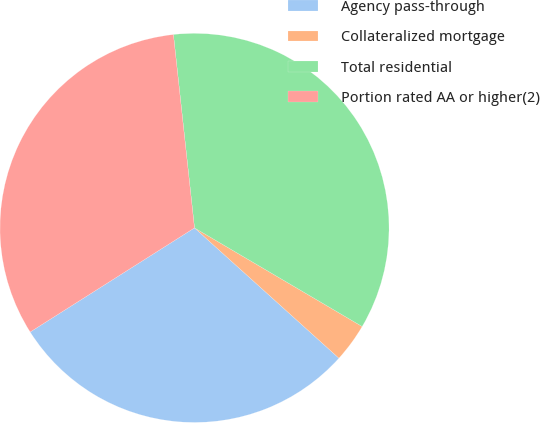<chart> <loc_0><loc_0><loc_500><loc_500><pie_chart><fcel>Agency pass-through<fcel>Collateralized mortgage<fcel>Total residential<fcel>Portion rated AA or higher(2)<nl><fcel>29.33%<fcel>3.22%<fcel>35.19%<fcel>32.26%<nl></chart> 